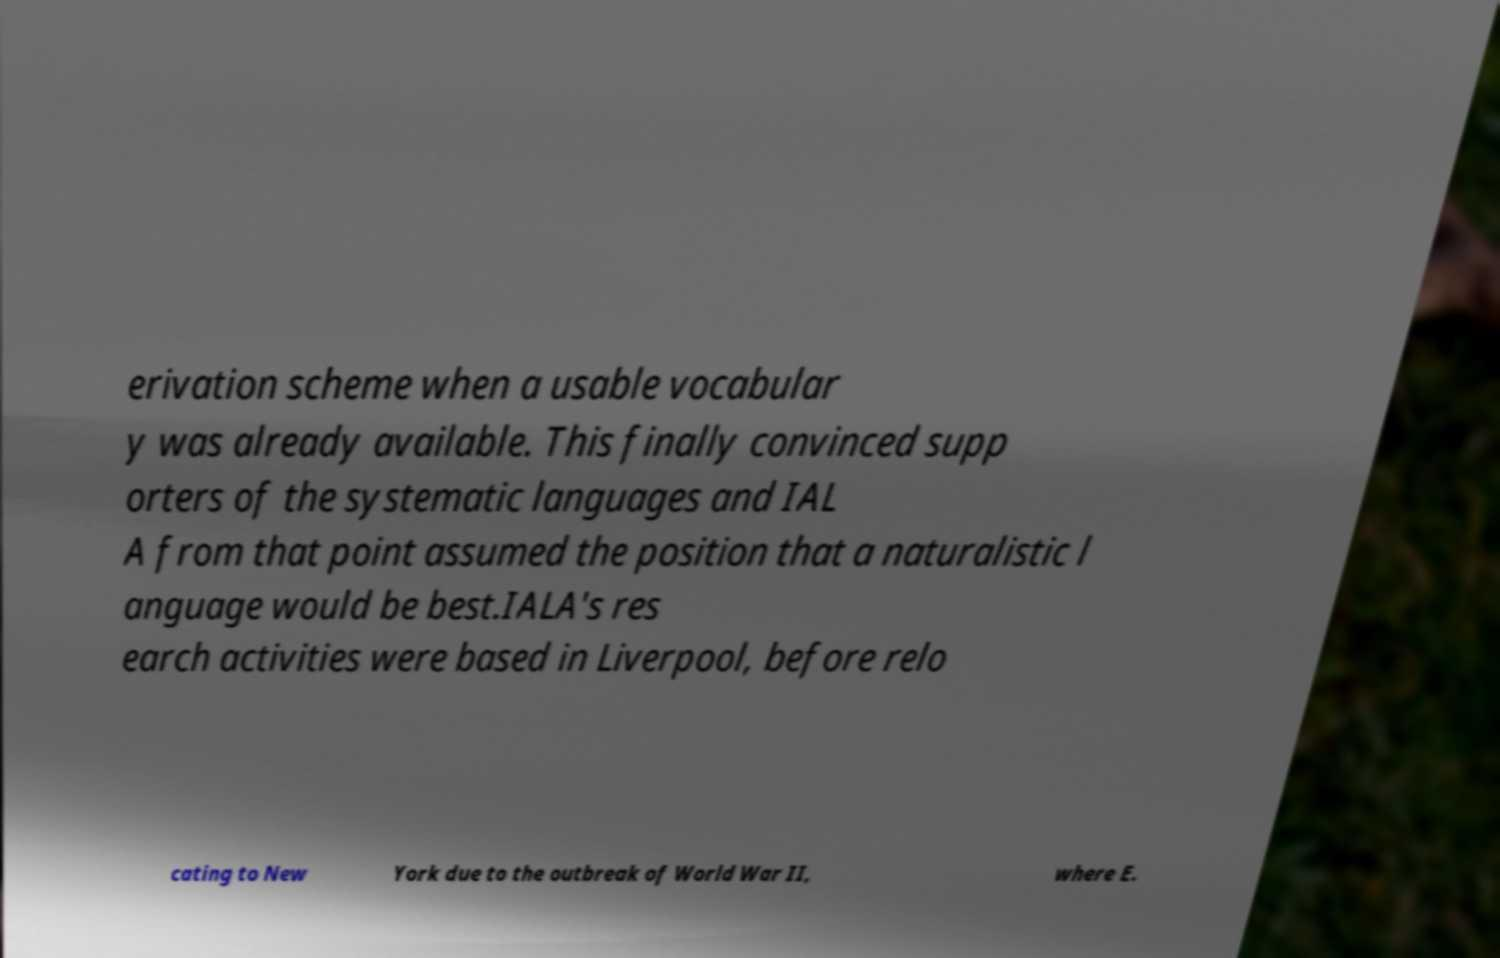Could you extract and type out the text from this image? erivation scheme when a usable vocabular y was already available. This finally convinced supp orters of the systematic languages and IAL A from that point assumed the position that a naturalistic l anguage would be best.IALA's res earch activities were based in Liverpool, before relo cating to New York due to the outbreak of World War II, where E. 